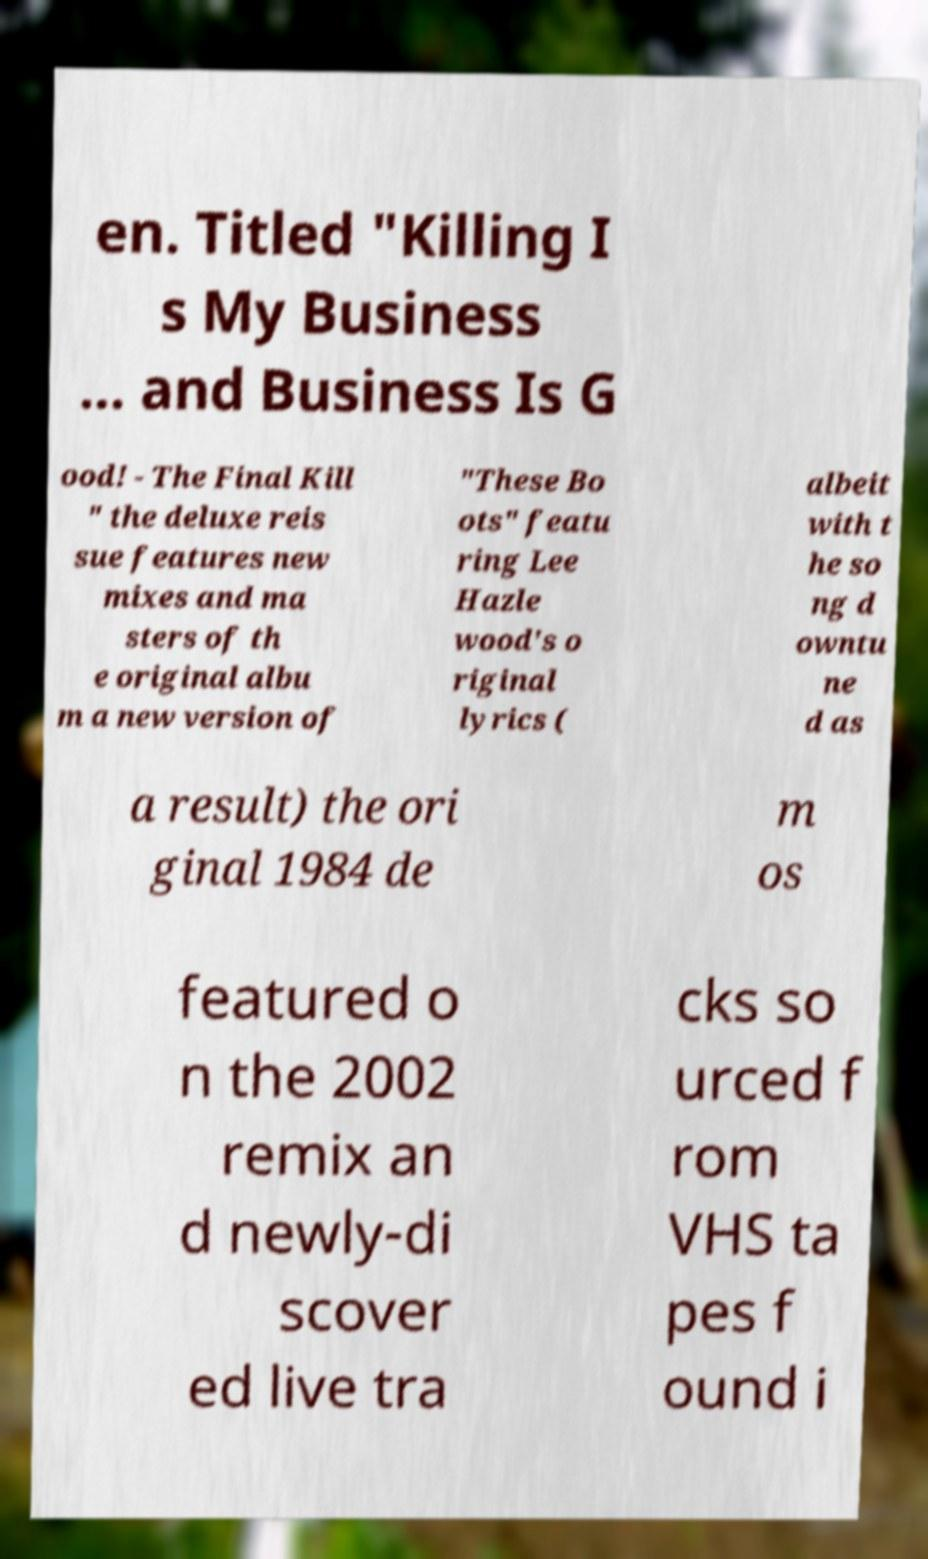Can you read and provide the text displayed in the image?This photo seems to have some interesting text. Can you extract and type it out for me? en. Titled "Killing I s My Business ... and Business Is G ood! - The Final Kill " the deluxe reis sue features new mixes and ma sters of th e original albu m a new version of "These Bo ots" featu ring Lee Hazle wood's o riginal lyrics ( albeit with t he so ng d owntu ne d as a result) the ori ginal 1984 de m os featured o n the 2002 remix an d newly-di scover ed live tra cks so urced f rom VHS ta pes f ound i 